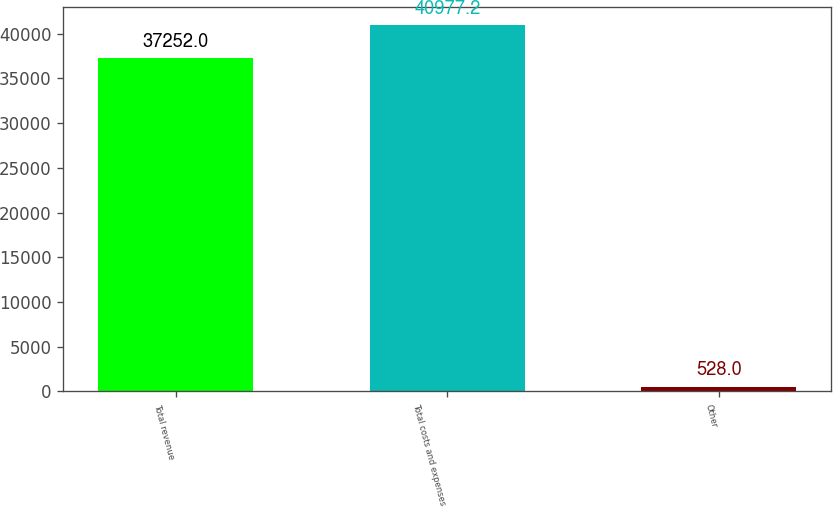Convert chart to OTSL. <chart><loc_0><loc_0><loc_500><loc_500><bar_chart><fcel>Total revenue<fcel>Total costs and expenses<fcel>Other<nl><fcel>37252<fcel>40977.2<fcel>528<nl></chart> 